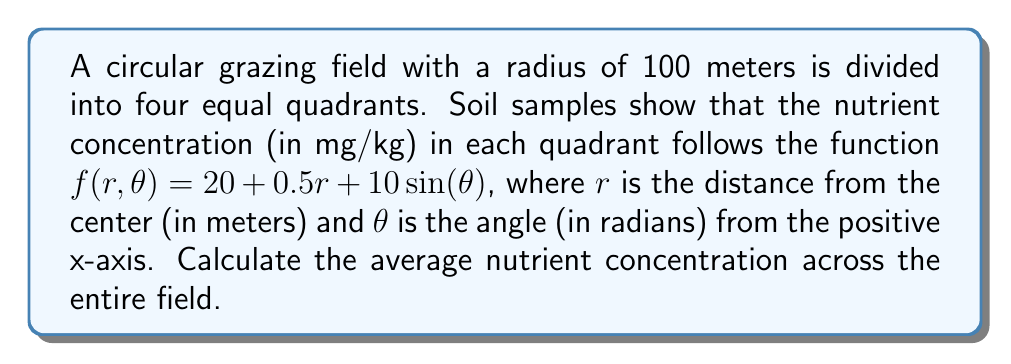Provide a solution to this math problem. To find the average nutrient concentration, we need to integrate the given function over the entire circular field and divide by the total area. Let's break this down step-by-step:

1) The area of the circular field is $A = \pi r^2 = \pi (100)^2 = 10000\pi$ square meters.

2) To integrate over a circular region, we use polar coordinates. The double integral for the total nutrient content is:

   $$\int_0^{2\pi} \int_0^{100} f(r,\theta) r dr d\theta$$

3) Substituting our function:

   $$\int_0^{2\pi} \int_0^{100} (20 + 0.5r + 10\sin(\theta)) r dr d\theta$$

4) Let's integrate with respect to r first:

   $$\int_0^{2\pi} \left[ 10r^2 + \frac{1}{6}r^3 + 10r\sin(\theta) \right]_0^{100} d\theta$$

5) Evaluating the inner integral:

   $$\int_0^{2\pi} (100000 + \frac{1000000}{6} + 1000\sin(\theta)) d\theta$$

6) Now integrate with respect to $\theta$:

   $$\left[ 100000\theta + \frac{1000000}{6}\theta - 1000\cos(\theta) \right]_0^{2\pi}$$

7) Evaluating at the limits:

   $$(200000\pi + \frac{1000000\pi}{3} - 1000\cos(2\pi)) - (0 - 1000\cos(0))$$
   
   $$= 200000\pi + \frac{1000000\pi}{3}$$

8) To get the average, divide by the area:

   $$\frac{200000\pi + \frac{1000000\pi}{3}}{10000\pi} = 20 + \frac{100}{3} = \frac{160}{3}$$

Therefore, the average nutrient concentration across the entire field is $\frac{160}{3}$ mg/kg.
Answer: $\frac{160}{3}$ mg/kg 